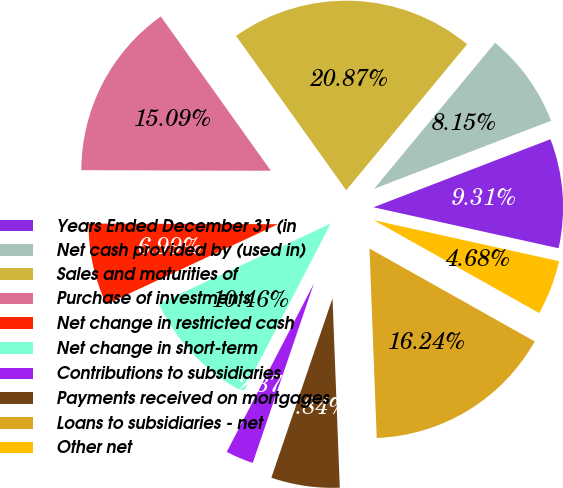Convert chart to OTSL. <chart><loc_0><loc_0><loc_500><loc_500><pie_chart><fcel>Years Ended December 31 (in<fcel>Net cash provided by (used in)<fcel>Sales and maturities of<fcel>Purchase of investments<fcel>Net change in restricted cash<fcel>Net change in short-term<fcel>Contributions to subsidiaries<fcel>Payments received on mortgages<fcel>Loans to subsidiaries - net<fcel>Other net<nl><fcel>9.31%<fcel>8.15%<fcel>20.87%<fcel>15.09%<fcel>6.99%<fcel>10.46%<fcel>2.37%<fcel>5.84%<fcel>16.24%<fcel>4.68%<nl></chart> 